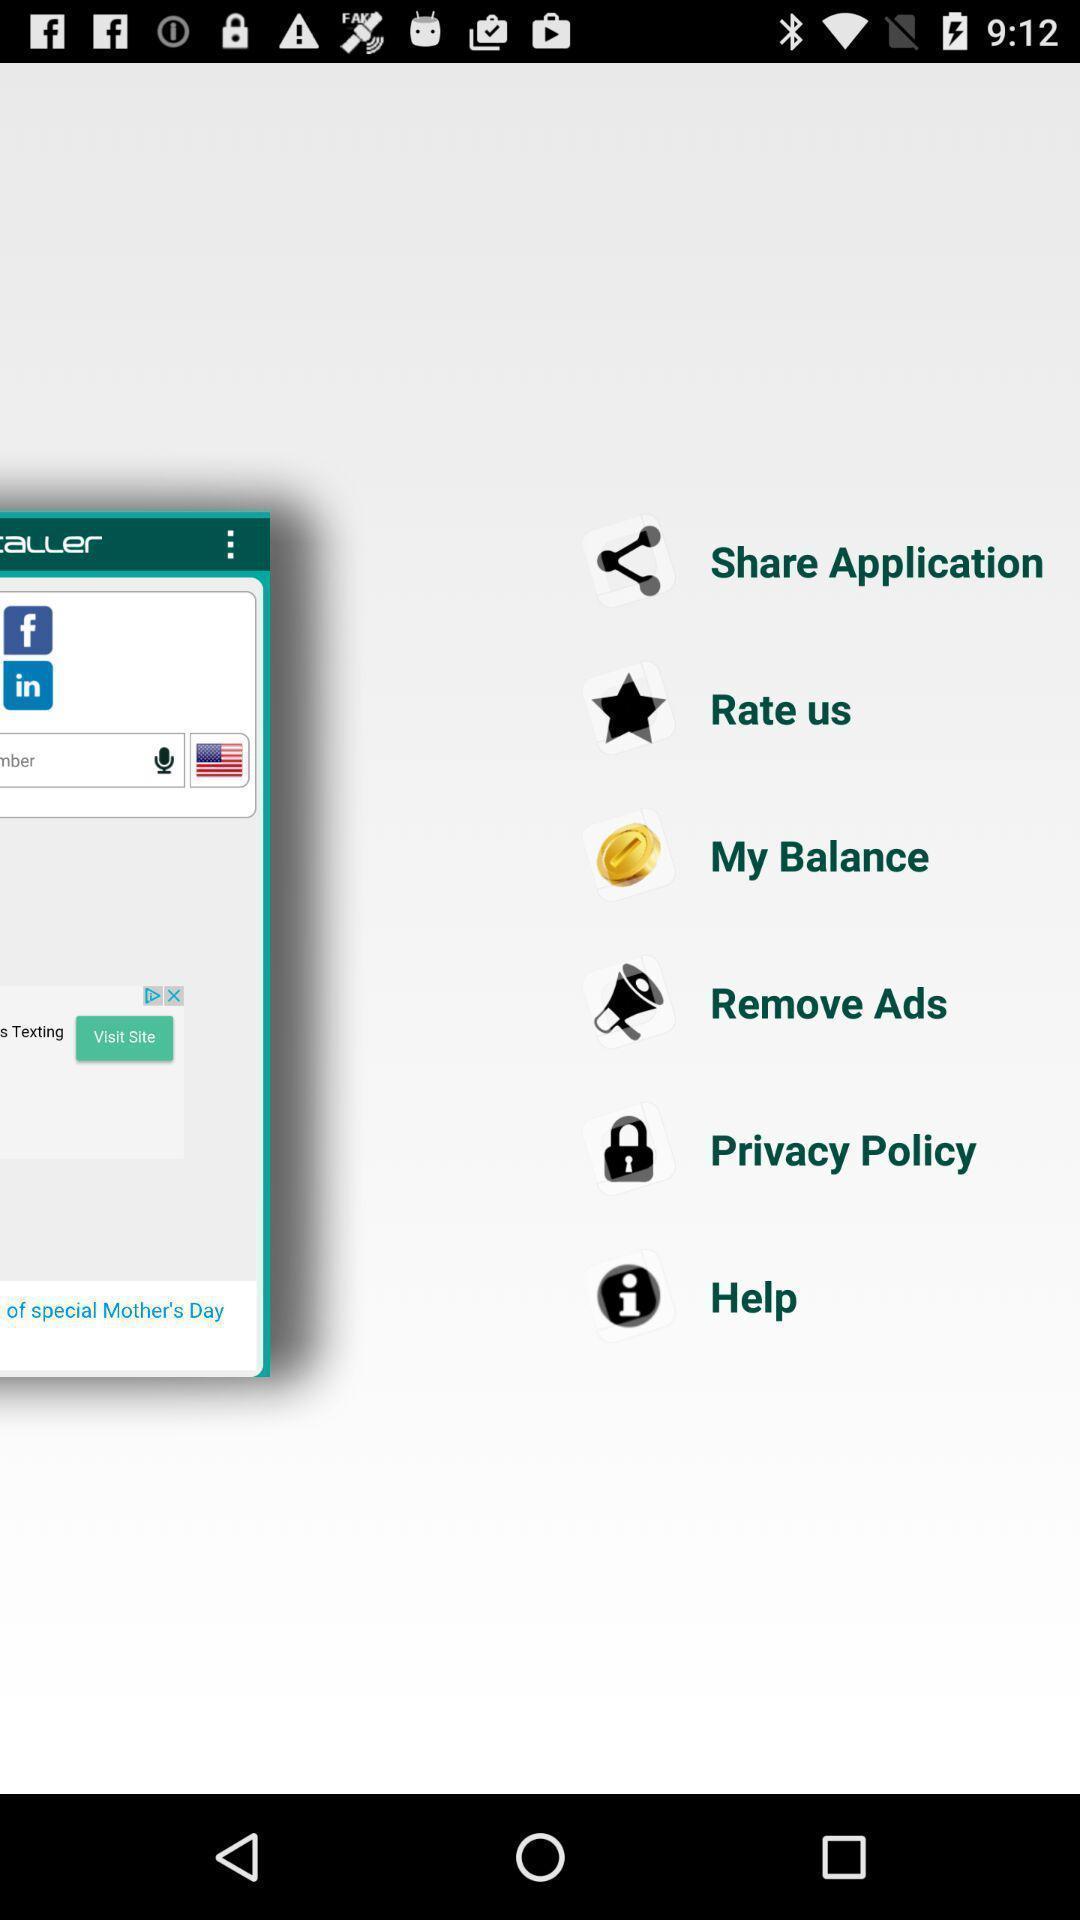Provide a detailed account of this screenshot. Page showing different options. 